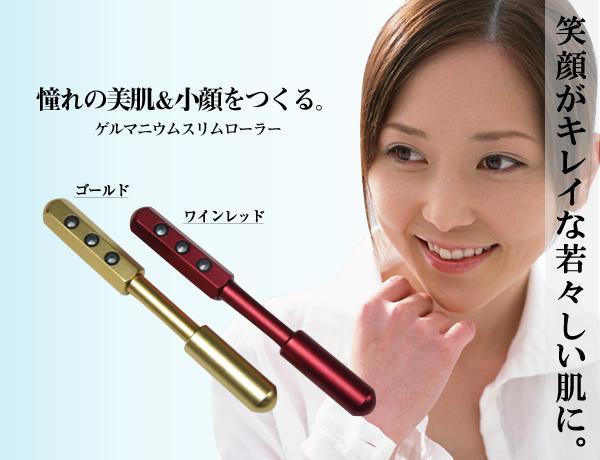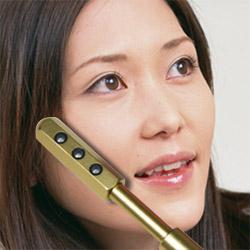The first image is the image on the left, the second image is the image on the right. For the images shown, is this caption "One image shows a woman with a flute touching her mouth." true? Answer yes or no. No. 